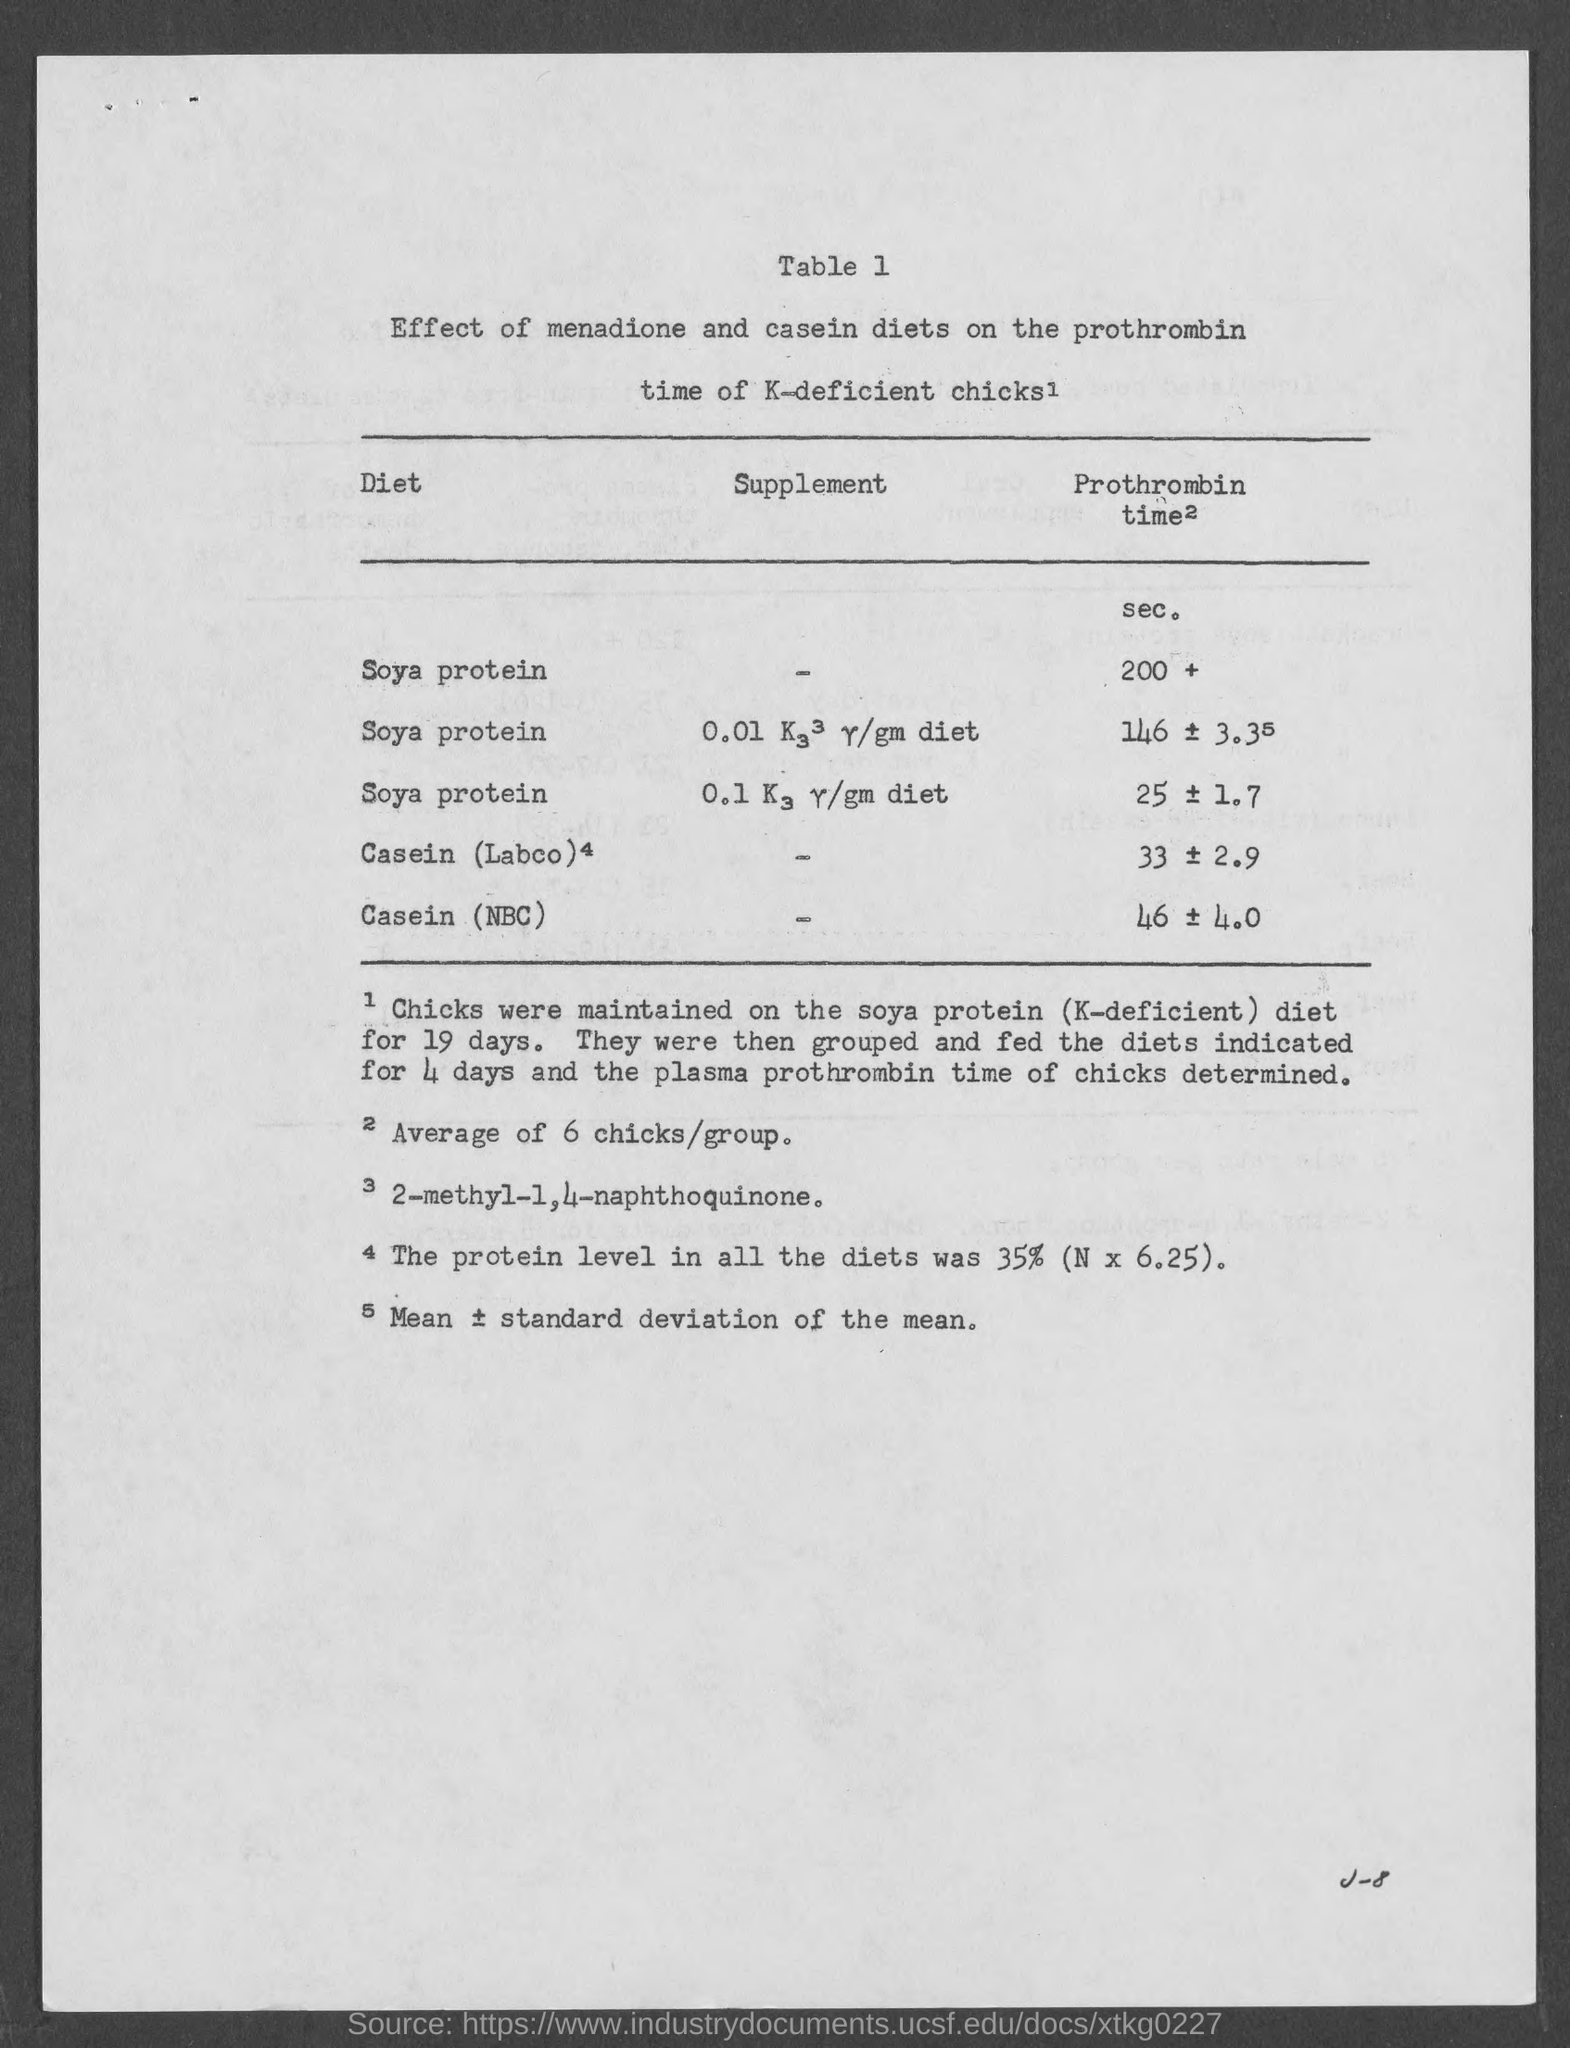Mention a couple of crucial points in this snapshot. The title of the first column of the table is 'Diet.' The title of the second column of the table is "Supplement". I am declaring that the table number is 1.. 